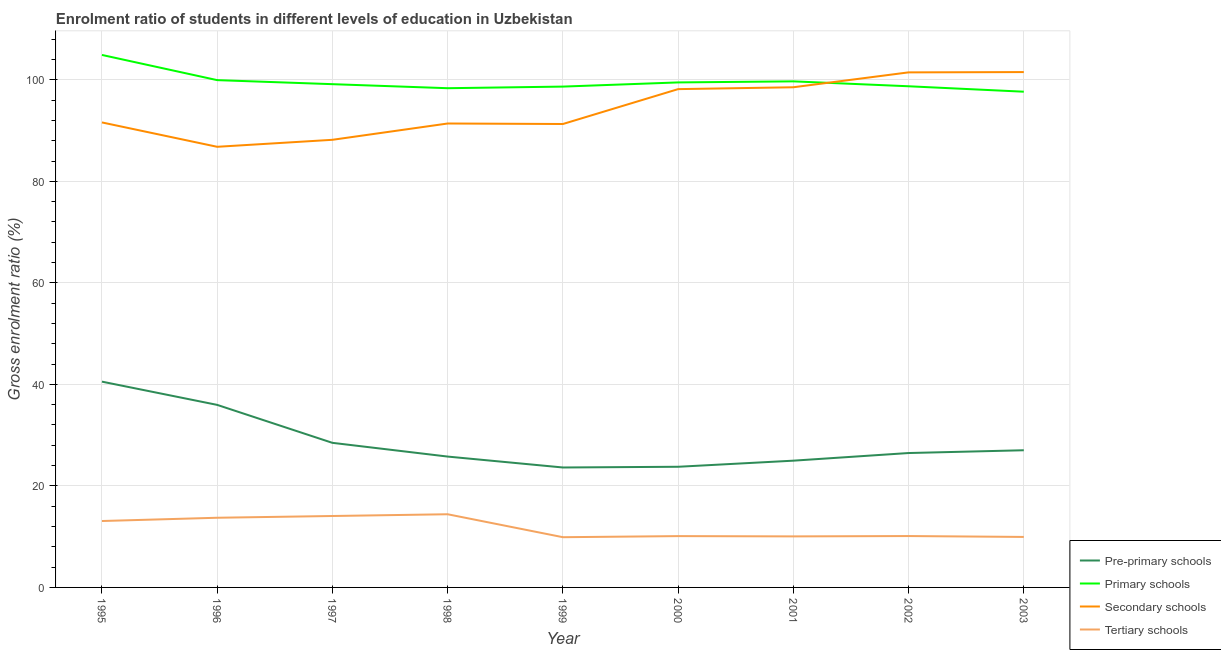How many different coloured lines are there?
Keep it short and to the point. 4. Does the line corresponding to gross enrolment ratio in pre-primary schools intersect with the line corresponding to gross enrolment ratio in secondary schools?
Offer a terse response. No. Is the number of lines equal to the number of legend labels?
Keep it short and to the point. Yes. What is the gross enrolment ratio in tertiary schools in 2003?
Your answer should be very brief. 9.95. Across all years, what is the maximum gross enrolment ratio in secondary schools?
Your answer should be compact. 101.52. Across all years, what is the minimum gross enrolment ratio in tertiary schools?
Your answer should be very brief. 9.9. In which year was the gross enrolment ratio in primary schools maximum?
Provide a succinct answer. 1995. In which year was the gross enrolment ratio in tertiary schools minimum?
Your answer should be very brief. 1999. What is the total gross enrolment ratio in secondary schools in the graph?
Ensure brevity in your answer.  848.95. What is the difference between the gross enrolment ratio in pre-primary schools in 2000 and that in 2002?
Your response must be concise. -2.71. What is the difference between the gross enrolment ratio in pre-primary schools in 2002 and the gross enrolment ratio in secondary schools in 1999?
Offer a very short reply. -64.82. What is the average gross enrolment ratio in primary schools per year?
Your answer should be very brief. 99.62. In the year 1998, what is the difference between the gross enrolment ratio in primary schools and gross enrolment ratio in secondary schools?
Give a very brief answer. 6.95. In how many years, is the gross enrolment ratio in primary schools greater than 20 %?
Your answer should be compact. 9. What is the ratio of the gross enrolment ratio in primary schools in 1999 to that in 2002?
Keep it short and to the point. 1. Is the gross enrolment ratio in secondary schools in 1996 less than that in 1999?
Offer a terse response. Yes. What is the difference between the highest and the second highest gross enrolment ratio in primary schools?
Keep it short and to the point. 4.96. What is the difference between the highest and the lowest gross enrolment ratio in primary schools?
Provide a succinct answer. 7.24. Is the sum of the gross enrolment ratio in pre-primary schools in 1995 and 1997 greater than the maximum gross enrolment ratio in tertiary schools across all years?
Offer a terse response. Yes. Is it the case that in every year, the sum of the gross enrolment ratio in secondary schools and gross enrolment ratio in primary schools is greater than the sum of gross enrolment ratio in tertiary schools and gross enrolment ratio in pre-primary schools?
Keep it short and to the point. Yes. How many lines are there?
Your answer should be compact. 4. How many years are there in the graph?
Give a very brief answer. 9. Are the values on the major ticks of Y-axis written in scientific E-notation?
Your response must be concise. No. Does the graph contain grids?
Provide a short and direct response. Yes. Where does the legend appear in the graph?
Ensure brevity in your answer.  Bottom right. What is the title of the graph?
Ensure brevity in your answer.  Enrolment ratio of students in different levels of education in Uzbekistan. Does "Secondary" appear as one of the legend labels in the graph?
Make the answer very short. No. What is the label or title of the X-axis?
Keep it short and to the point. Year. What is the Gross enrolment ratio (%) of Pre-primary schools in 1995?
Give a very brief answer. 40.54. What is the Gross enrolment ratio (%) of Primary schools in 1995?
Offer a terse response. 104.9. What is the Gross enrolment ratio (%) in Secondary schools in 1995?
Make the answer very short. 91.6. What is the Gross enrolment ratio (%) of Tertiary schools in 1995?
Keep it short and to the point. 13.08. What is the Gross enrolment ratio (%) of Pre-primary schools in 1996?
Provide a succinct answer. 35.96. What is the Gross enrolment ratio (%) of Primary schools in 1996?
Offer a terse response. 99.94. What is the Gross enrolment ratio (%) in Secondary schools in 1996?
Keep it short and to the point. 86.8. What is the Gross enrolment ratio (%) of Tertiary schools in 1996?
Your response must be concise. 13.73. What is the Gross enrolment ratio (%) of Pre-primary schools in 1997?
Make the answer very short. 28.48. What is the Gross enrolment ratio (%) of Primary schools in 1997?
Provide a succinct answer. 99.14. What is the Gross enrolment ratio (%) in Secondary schools in 1997?
Provide a short and direct response. 88.18. What is the Gross enrolment ratio (%) in Tertiary schools in 1997?
Your answer should be compact. 14.07. What is the Gross enrolment ratio (%) in Pre-primary schools in 1998?
Offer a very short reply. 25.78. What is the Gross enrolment ratio (%) of Primary schools in 1998?
Offer a terse response. 98.34. What is the Gross enrolment ratio (%) in Secondary schools in 1998?
Offer a very short reply. 91.39. What is the Gross enrolment ratio (%) of Tertiary schools in 1998?
Ensure brevity in your answer.  14.41. What is the Gross enrolment ratio (%) in Pre-primary schools in 1999?
Make the answer very short. 23.63. What is the Gross enrolment ratio (%) of Primary schools in 1999?
Keep it short and to the point. 98.66. What is the Gross enrolment ratio (%) in Secondary schools in 1999?
Provide a succinct answer. 91.29. What is the Gross enrolment ratio (%) of Tertiary schools in 1999?
Give a very brief answer. 9.9. What is the Gross enrolment ratio (%) in Pre-primary schools in 2000?
Offer a terse response. 23.77. What is the Gross enrolment ratio (%) of Primary schools in 2000?
Offer a terse response. 99.48. What is the Gross enrolment ratio (%) in Secondary schools in 2000?
Give a very brief answer. 98.16. What is the Gross enrolment ratio (%) in Tertiary schools in 2000?
Your response must be concise. 10.11. What is the Gross enrolment ratio (%) of Pre-primary schools in 2001?
Offer a very short reply. 24.97. What is the Gross enrolment ratio (%) of Primary schools in 2001?
Your response must be concise. 99.69. What is the Gross enrolment ratio (%) of Secondary schools in 2001?
Offer a terse response. 98.53. What is the Gross enrolment ratio (%) in Tertiary schools in 2001?
Give a very brief answer. 10.06. What is the Gross enrolment ratio (%) of Pre-primary schools in 2002?
Make the answer very short. 26.47. What is the Gross enrolment ratio (%) of Primary schools in 2002?
Keep it short and to the point. 98.73. What is the Gross enrolment ratio (%) of Secondary schools in 2002?
Your response must be concise. 101.46. What is the Gross enrolment ratio (%) in Tertiary schools in 2002?
Provide a short and direct response. 10.12. What is the Gross enrolment ratio (%) in Pre-primary schools in 2003?
Provide a succinct answer. 27.02. What is the Gross enrolment ratio (%) of Primary schools in 2003?
Ensure brevity in your answer.  97.65. What is the Gross enrolment ratio (%) of Secondary schools in 2003?
Offer a very short reply. 101.52. What is the Gross enrolment ratio (%) of Tertiary schools in 2003?
Your answer should be very brief. 9.95. Across all years, what is the maximum Gross enrolment ratio (%) of Pre-primary schools?
Your answer should be very brief. 40.54. Across all years, what is the maximum Gross enrolment ratio (%) of Primary schools?
Offer a terse response. 104.9. Across all years, what is the maximum Gross enrolment ratio (%) of Secondary schools?
Ensure brevity in your answer.  101.52. Across all years, what is the maximum Gross enrolment ratio (%) of Tertiary schools?
Ensure brevity in your answer.  14.41. Across all years, what is the minimum Gross enrolment ratio (%) in Pre-primary schools?
Provide a succinct answer. 23.63. Across all years, what is the minimum Gross enrolment ratio (%) in Primary schools?
Your response must be concise. 97.65. Across all years, what is the minimum Gross enrolment ratio (%) in Secondary schools?
Offer a very short reply. 86.8. Across all years, what is the minimum Gross enrolment ratio (%) in Tertiary schools?
Give a very brief answer. 9.9. What is the total Gross enrolment ratio (%) of Pre-primary schools in the graph?
Your answer should be compact. 256.62. What is the total Gross enrolment ratio (%) of Primary schools in the graph?
Provide a short and direct response. 896.54. What is the total Gross enrolment ratio (%) of Secondary schools in the graph?
Ensure brevity in your answer.  848.95. What is the total Gross enrolment ratio (%) in Tertiary schools in the graph?
Offer a very short reply. 105.42. What is the difference between the Gross enrolment ratio (%) in Pre-primary schools in 1995 and that in 1996?
Offer a terse response. 4.58. What is the difference between the Gross enrolment ratio (%) of Primary schools in 1995 and that in 1996?
Provide a short and direct response. 4.96. What is the difference between the Gross enrolment ratio (%) of Secondary schools in 1995 and that in 1996?
Provide a short and direct response. 4.8. What is the difference between the Gross enrolment ratio (%) in Tertiary schools in 1995 and that in 1996?
Provide a succinct answer. -0.64. What is the difference between the Gross enrolment ratio (%) in Pre-primary schools in 1995 and that in 1997?
Your answer should be very brief. 12.06. What is the difference between the Gross enrolment ratio (%) in Primary schools in 1995 and that in 1997?
Keep it short and to the point. 5.76. What is the difference between the Gross enrolment ratio (%) in Secondary schools in 1995 and that in 1997?
Your answer should be compact. 3.42. What is the difference between the Gross enrolment ratio (%) in Tertiary schools in 1995 and that in 1997?
Provide a succinct answer. -0.99. What is the difference between the Gross enrolment ratio (%) in Pre-primary schools in 1995 and that in 1998?
Make the answer very short. 14.76. What is the difference between the Gross enrolment ratio (%) in Primary schools in 1995 and that in 1998?
Offer a very short reply. 6.55. What is the difference between the Gross enrolment ratio (%) of Secondary schools in 1995 and that in 1998?
Provide a succinct answer. 0.21. What is the difference between the Gross enrolment ratio (%) of Tertiary schools in 1995 and that in 1998?
Your answer should be compact. -1.33. What is the difference between the Gross enrolment ratio (%) in Pre-primary schools in 1995 and that in 1999?
Ensure brevity in your answer.  16.91. What is the difference between the Gross enrolment ratio (%) in Primary schools in 1995 and that in 1999?
Give a very brief answer. 6.24. What is the difference between the Gross enrolment ratio (%) in Secondary schools in 1995 and that in 1999?
Your answer should be very brief. 0.31. What is the difference between the Gross enrolment ratio (%) of Tertiary schools in 1995 and that in 1999?
Ensure brevity in your answer.  3.19. What is the difference between the Gross enrolment ratio (%) of Pre-primary schools in 1995 and that in 2000?
Offer a very short reply. 16.77. What is the difference between the Gross enrolment ratio (%) in Primary schools in 1995 and that in 2000?
Offer a terse response. 5.41. What is the difference between the Gross enrolment ratio (%) in Secondary schools in 1995 and that in 2000?
Your response must be concise. -6.56. What is the difference between the Gross enrolment ratio (%) in Tertiary schools in 1995 and that in 2000?
Make the answer very short. 2.97. What is the difference between the Gross enrolment ratio (%) of Pre-primary schools in 1995 and that in 2001?
Make the answer very short. 15.57. What is the difference between the Gross enrolment ratio (%) of Primary schools in 1995 and that in 2001?
Ensure brevity in your answer.  5.2. What is the difference between the Gross enrolment ratio (%) in Secondary schools in 1995 and that in 2001?
Your answer should be compact. -6.93. What is the difference between the Gross enrolment ratio (%) in Tertiary schools in 1995 and that in 2001?
Offer a terse response. 3.03. What is the difference between the Gross enrolment ratio (%) in Pre-primary schools in 1995 and that in 2002?
Offer a very short reply. 14.06. What is the difference between the Gross enrolment ratio (%) of Primary schools in 1995 and that in 2002?
Your answer should be very brief. 6.17. What is the difference between the Gross enrolment ratio (%) in Secondary schools in 1995 and that in 2002?
Provide a short and direct response. -9.86. What is the difference between the Gross enrolment ratio (%) in Tertiary schools in 1995 and that in 2002?
Provide a succinct answer. 2.96. What is the difference between the Gross enrolment ratio (%) in Pre-primary schools in 1995 and that in 2003?
Keep it short and to the point. 13.52. What is the difference between the Gross enrolment ratio (%) in Primary schools in 1995 and that in 2003?
Offer a terse response. 7.24. What is the difference between the Gross enrolment ratio (%) in Secondary schools in 1995 and that in 2003?
Offer a terse response. -9.92. What is the difference between the Gross enrolment ratio (%) of Tertiary schools in 1995 and that in 2003?
Keep it short and to the point. 3.14. What is the difference between the Gross enrolment ratio (%) of Pre-primary schools in 1996 and that in 1997?
Keep it short and to the point. 7.48. What is the difference between the Gross enrolment ratio (%) of Primary schools in 1996 and that in 1997?
Keep it short and to the point. 0.8. What is the difference between the Gross enrolment ratio (%) in Secondary schools in 1996 and that in 1997?
Give a very brief answer. -1.38. What is the difference between the Gross enrolment ratio (%) of Tertiary schools in 1996 and that in 1997?
Your answer should be very brief. -0.34. What is the difference between the Gross enrolment ratio (%) of Pre-primary schools in 1996 and that in 1998?
Provide a short and direct response. 10.18. What is the difference between the Gross enrolment ratio (%) of Primary schools in 1996 and that in 1998?
Offer a terse response. 1.59. What is the difference between the Gross enrolment ratio (%) in Secondary schools in 1996 and that in 1998?
Make the answer very short. -4.59. What is the difference between the Gross enrolment ratio (%) in Tertiary schools in 1996 and that in 1998?
Keep it short and to the point. -0.69. What is the difference between the Gross enrolment ratio (%) of Pre-primary schools in 1996 and that in 1999?
Your answer should be compact. 12.33. What is the difference between the Gross enrolment ratio (%) of Primary schools in 1996 and that in 1999?
Give a very brief answer. 1.27. What is the difference between the Gross enrolment ratio (%) of Secondary schools in 1996 and that in 1999?
Your answer should be very brief. -4.49. What is the difference between the Gross enrolment ratio (%) of Tertiary schools in 1996 and that in 1999?
Offer a terse response. 3.83. What is the difference between the Gross enrolment ratio (%) of Pre-primary schools in 1996 and that in 2000?
Make the answer very short. 12.19. What is the difference between the Gross enrolment ratio (%) in Primary schools in 1996 and that in 2000?
Your answer should be very brief. 0.45. What is the difference between the Gross enrolment ratio (%) in Secondary schools in 1996 and that in 2000?
Offer a very short reply. -11.36. What is the difference between the Gross enrolment ratio (%) in Tertiary schools in 1996 and that in 2000?
Your response must be concise. 3.62. What is the difference between the Gross enrolment ratio (%) in Pre-primary schools in 1996 and that in 2001?
Ensure brevity in your answer.  10.99. What is the difference between the Gross enrolment ratio (%) in Primary schools in 1996 and that in 2001?
Give a very brief answer. 0.24. What is the difference between the Gross enrolment ratio (%) in Secondary schools in 1996 and that in 2001?
Ensure brevity in your answer.  -11.73. What is the difference between the Gross enrolment ratio (%) of Tertiary schools in 1996 and that in 2001?
Offer a very short reply. 3.67. What is the difference between the Gross enrolment ratio (%) of Pre-primary schools in 1996 and that in 2002?
Your answer should be very brief. 9.49. What is the difference between the Gross enrolment ratio (%) in Primary schools in 1996 and that in 2002?
Provide a succinct answer. 1.21. What is the difference between the Gross enrolment ratio (%) of Secondary schools in 1996 and that in 2002?
Make the answer very short. -14.66. What is the difference between the Gross enrolment ratio (%) in Tertiary schools in 1996 and that in 2002?
Your answer should be compact. 3.6. What is the difference between the Gross enrolment ratio (%) of Pre-primary schools in 1996 and that in 2003?
Your response must be concise. 8.94. What is the difference between the Gross enrolment ratio (%) in Primary schools in 1996 and that in 2003?
Offer a very short reply. 2.28. What is the difference between the Gross enrolment ratio (%) in Secondary schools in 1996 and that in 2003?
Provide a short and direct response. -14.72. What is the difference between the Gross enrolment ratio (%) in Tertiary schools in 1996 and that in 2003?
Keep it short and to the point. 3.78. What is the difference between the Gross enrolment ratio (%) in Pre-primary schools in 1997 and that in 1998?
Offer a terse response. 2.7. What is the difference between the Gross enrolment ratio (%) of Primary schools in 1997 and that in 1998?
Keep it short and to the point. 0.8. What is the difference between the Gross enrolment ratio (%) in Secondary schools in 1997 and that in 1998?
Ensure brevity in your answer.  -3.21. What is the difference between the Gross enrolment ratio (%) in Tertiary schools in 1997 and that in 1998?
Make the answer very short. -0.34. What is the difference between the Gross enrolment ratio (%) in Pre-primary schools in 1997 and that in 1999?
Your answer should be compact. 4.85. What is the difference between the Gross enrolment ratio (%) in Primary schools in 1997 and that in 1999?
Ensure brevity in your answer.  0.48. What is the difference between the Gross enrolment ratio (%) of Secondary schools in 1997 and that in 1999?
Provide a short and direct response. -3.11. What is the difference between the Gross enrolment ratio (%) of Tertiary schools in 1997 and that in 1999?
Ensure brevity in your answer.  4.18. What is the difference between the Gross enrolment ratio (%) of Pre-primary schools in 1997 and that in 2000?
Your response must be concise. 4.71. What is the difference between the Gross enrolment ratio (%) in Primary schools in 1997 and that in 2000?
Ensure brevity in your answer.  -0.34. What is the difference between the Gross enrolment ratio (%) of Secondary schools in 1997 and that in 2000?
Give a very brief answer. -9.98. What is the difference between the Gross enrolment ratio (%) of Tertiary schools in 1997 and that in 2000?
Keep it short and to the point. 3.96. What is the difference between the Gross enrolment ratio (%) in Pre-primary schools in 1997 and that in 2001?
Provide a succinct answer. 3.51. What is the difference between the Gross enrolment ratio (%) of Primary schools in 1997 and that in 2001?
Your response must be concise. -0.55. What is the difference between the Gross enrolment ratio (%) of Secondary schools in 1997 and that in 2001?
Your answer should be compact. -10.35. What is the difference between the Gross enrolment ratio (%) of Tertiary schools in 1997 and that in 2001?
Your response must be concise. 4.02. What is the difference between the Gross enrolment ratio (%) in Pre-primary schools in 1997 and that in 2002?
Provide a succinct answer. 2.01. What is the difference between the Gross enrolment ratio (%) in Primary schools in 1997 and that in 2002?
Offer a very short reply. 0.41. What is the difference between the Gross enrolment ratio (%) in Secondary schools in 1997 and that in 2002?
Make the answer very short. -13.28. What is the difference between the Gross enrolment ratio (%) of Tertiary schools in 1997 and that in 2002?
Provide a succinct answer. 3.95. What is the difference between the Gross enrolment ratio (%) in Pre-primary schools in 1997 and that in 2003?
Your answer should be compact. 1.46. What is the difference between the Gross enrolment ratio (%) in Primary schools in 1997 and that in 2003?
Make the answer very short. 1.49. What is the difference between the Gross enrolment ratio (%) of Secondary schools in 1997 and that in 2003?
Offer a terse response. -13.34. What is the difference between the Gross enrolment ratio (%) in Tertiary schools in 1997 and that in 2003?
Provide a succinct answer. 4.12. What is the difference between the Gross enrolment ratio (%) in Pre-primary schools in 1998 and that in 1999?
Your answer should be compact. 2.15. What is the difference between the Gross enrolment ratio (%) of Primary schools in 1998 and that in 1999?
Give a very brief answer. -0.32. What is the difference between the Gross enrolment ratio (%) of Secondary schools in 1998 and that in 1999?
Offer a very short reply. 0.1. What is the difference between the Gross enrolment ratio (%) in Tertiary schools in 1998 and that in 1999?
Your answer should be compact. 4.52. What is the difference between the Gross enrolment ratio (%) of Pre-primary schools in 1998 and that in 2000?
Your response must be concise. 2.01. What is the difference between the Gross enrolment ratio (%) in Primary schools in 1998 and that in 2000?
Your answer should be very brief. -1.14. What is the difference between the Gross enrolment ratio (%) in Secondary schools in 1998 and that in 2000?
Your response must be concise. -6.77. What is the difference between the Gross enrolment ratio (%) in Tertiary schools in 1998 and that in 2000?
Give a very brief answer. 4.3. What is the difference between the Gross enrolment ratio (%) of Pre-primary schools in 1998 and that in 2001?
Your answer should be very brief. 0.81. What is the difference between the Gross enrolment ratio (%) of Primary schools in 1998 and that in 2001?
Offer a terse response. -1.35. What is the difference between the Gross enrolment ratio (%) in Secondary schools in 1998 and that in 2001?
Keep it short and to the point. -7.14. What is the difference between the Gross enrolment ratio (%) in Tertiary schools in 1998 and that in 2001?
Provide a short and direct response. 4.36. What is the difference between the Gross enrolment ratio (%) of Pre-primary schools in 1998 and that in 2002?
Make the answer very short. -0.7. What is the difference between the Gross enrolment ratio (%) of Primary schools in 1998 and that in 2002?
Provide a short and direct response. -0.38. What is the difference between the Gross enrolment ratio (%) in Secondary schools in 1998 and that in 2002?
Provide a succinct answer. -10.07. What is the difference between the Gross enrolment ratio (%) in Tertiary schools in 1998 and that in 2002?
Offer a terse response. 4.29. What is the difference between the Gross enrolment ratio (%) of Pre-primary schools in 1998 and that in 2003?
Make the answer very short. -1.24. What is the difference between the Gross enrolment ratio (%) of Primary schools in 1998 and that in 2003?
Provide a succinct answer. 0.69. What is the difference between the Gross enrolment ratio (%) in Secondary schools in 1998 and that in 2003?
Give a very brief answer. -10.13. What is the difference between the Gross enrolment ratio (%) in Tertiary schools in 1998 and that in 2003?
Provide a short and direct response. 4.47. What is the difference between the Gross enrolment ratio (%) of Pre-primary schools in 1999 and that in 2000?
Make the answer very short. -0.14. What is the difference between the Gross enrolment ratio (%) in Primary schools in 1999 and that in 2000?
Give a very brief answer. -0.82. What is the difference between the Gross enrolment ratio (%) in Secondary schools in 1999 and that in 2000?
Give a very brief answer. -6.87. What is the difference between the Gross enrolment ratio (%) in Tertiary schools in 1999 and that in 2000?
Provide a succinct answer. -0.21. What is the difference between the Gross enrolment ratio (%) of Pre-primary schools in 1999 and that in 2001?
Offer a very short reply. -1.34. What is the difference between the Gross enrolment ratio (%) in Primary schools in 1999 and that in 2001?
Your answer should be very brief. -1.03. What is the difference between the Gross enrolment ratio (%) in Secondary schools in 1999 and that in 2001?
Keep it short and to the point. -7.24. What is the difference between the Gross enrolment ratio (%) of Tertiary schools in 1999 and that in 2001?
Give a very brief answer. -0.16. What is the difference between the Gross enrolment ratio (%) of Pre-primary schools in 1999 and that in 2002?
Make the answer very short. -2.85. What is the difference between the Gross enrolment ratio (%) of Primary schools in 1999 and that in 2002?
Offer a very short reply. -0.06. What is the difference between the Gross enrolment ratio (%) of Secondary schools in 1999 and that in 2002?
Your answer should be compact. -10.17. What is the difference between the Gross enrolment ratio (%) in Tertiary schools in 1999 and that in 2002?
Your answer should be very brief. -0.23. What is the difference between the Gross enrolment ratio (%) of Pre-primary schools in 1999 and that in 2003?
Give a very brief answer. -3.39. What is the difference between the Gross enrolment ratio (%) in Secondary schools in 1999 and that in 2003?
Your answer should be very brief. -10.23. What is the difference between the Gross enrolment ratio (%) of Tertiary schools in 1999 and that in 2003?
Provide a succinct answer. -0.05. What is the difference between the Gross enrolment ratio (%) in Pre-primary schools in 2000 and that in 2001?
Provide a succinct answer. -1.2. What is the difference between the Gross enrolment ratio (%) of Primary schools in 2000 and that in 2001?
Offer a terse response. -0.21. What is the difference between the Gross enrolment ratio (%) in Secondary schools in 2000 and that in 2001?
Make the answer very short. -0.37. What is the difference between the Gross enrolment ratio (%) in Tertiary schools in 2000 and that in 2001?
Keep it short and to the point. 0.05. What is the difference between the Gross enrolment ratio (%) of Pre-primary schools in 2000 and that in 2002?
Your response must be concise. -2.71. What is the difference between the Gross enrolment ratio (%) in Primary schools in 2000 and that in 2002?
Give a very brief answer. 0.76. What is the difference between the Gross enrolment ratio (%) of Secondary schools in 2000 and that in 2002?
Ensure brevity in your answer.  -3.3. What is the difference between the Gross enrolment ratio (%) of Tertiary schools in 2000 and that in 2002?
Provide a short and direct response. -0.01. What is the difference between the Gross enrolment ratio (%) of Pre-primary schools in 2000 and that in 2003?
Keep it short and to the point. -3.25. What is the difference between the Gross enrolment ratio (%) in Primary schools in 2000 and that in 2003?
Ensure brevity in your answer.  1.83. What is the difference between the Gross enrolment ratio (%) of Secondary schools in 2000 and that in 2003?
Your answer should be compact. -3.36. What is the difference between the Gross enrolment ratio (%) of Tertiary schools in 2000 and that in 2003?
Provide a succinct answer. 0.16. What is the difference between the Gross enrolment ratio (%) in Pre-primary schools in 2001 and that in 2002?
Offer a terse response. -1.5. What is the difference between the Gross enrolment ratio (%) in Primary schools in 2001 and that in 2002?
Give a very brief answer. 0.97. What is the difference between the Gross enrolment ratio (%) in Secondary schools in 2001 and that in 2002?
Offer a terse response. -2.93. What is the difference between the Gross enrolment ratio (%) in Tertiary schools in 2001 and that in 2002?
Offer a very short reply. -0.07. What is the difference between the Gross enrolment ratio (%) in Pre-primary schools in 2001 and that in 2003?
Give a very brief answer. -2.05. What is the difference between the Gross enrolment ratio (%) in Primary schools in 2001 and that in 2003?
Provide a succinct answer. 2.04. What is the difference between the Gross enrolment ratio (%) of Secondary schools in 2001 and that in 2003?
Give a very brief answer. -2.99. What is the difference between the Gross enrolment ratio (%) in Tertiary schools in 2001 and that in 2003?
Make the answer very short. 0.11. What is the difference between the Gross enrolment ratio (%) in Pre-primary schools in 2002 and that in 2003?
Your response must be concise. -0.55. What is the difference between the Gross enrolment ratio (%) in Primary schools in 2002 and that in 2003?
Your response must be concise. 1.07. What is the difference between the Gross enrolment ratio (%) of Secondary schools in 2002 and that in 2003?
Your response must be concise. -0.06. What is the difference between the Gross enrolment ratio (%) of Tertiary schools in 2002 and that in 2003?
Provide a succinct answer. 0.17. What is the difference between the Gross enrolment ratio (%) in Pre-primary schools in 1995 and the Gross enrolment ratio (%) in Primary schools in 1996?
Offer a terse response. -59.4. What is the difference between the Gross enrolment ratio (%) of Pre-primary schools in 1995 and the Gross enrolment ratio (%) of Secondary schools in 1996?
Make the answer very short. -46.26. What is the difference between the Gross enrolment ratio (%) in Pre-primary schools in 1995 and the Gross enrolment ratio (%) in Tertiary schools in 1996?
Offer a very short reply. 26.81. What is the difference between the Gross enrolment ratio (%) in Primary schools in 1995 and the Gross enrolment ratio (%) in Secondary schools in 1996?
Ensure brevity in your answer.  18.1. What is the difference between the Gross enrolment ratio (%) of Primary schools in 1995 and the Gross enrolment ratio (%) of Tertiary schools in 1996?
Provide a succinct answer. 91.17. What is the difference between the Gross enrolment ratio (%) in Secondary schools in 1995 and the Gross enrolment ratio (%) in Tertiary schools in 1996?
Ensure brevity in your answer.  77.88. What is the difference between the Gross enrolment ratio (%) of Pre-primary schools in 1995 and the Gross enrolment ratio (%) of Primary schools in 1997?
Make the answer very short. -58.6. What is the difference between the Gross enrolment ratio (%) in Pre-primary schools in 1995 and the Gross enrolment ratio (%) in Secondary schools in 1997?
Ensure brevity in your answer.  -47.64. What is the difference between the Gross enrolment ratio (%) of Pre-primary schools in 1995 and the Gross enrolment ratio (%) of Tertiary schools in 1997?
Make the answer very short. 26.47. What is the difference between the Gross enrolment ratio (%) in Primary schools in 1995 and the Gross enrolment ratio (%) in Secondary schools in 1997?
Give a very brief answer. 16.72. What is the difference between the Gross enrolment ratio (%) in Primary schools in 1995 and the Gross enrolment ratio (%) in Tertiary schools in 1997?
Ensure brevity in your answer.  90.83. What is the difference between the Gross enrolment ratio (%) of Secondary schools in 1995 and the Gross enrolment ratio (%) of Tertiary schools in 1997?
Keep it short and to the point. 77.53. What is the difference between the Gross enrolment ratio (%) of Pre-primary schools in 1995 and the Gross enrolment ratio (%) of Primary schools in 1998?
Your response must be concise. -57.8. What is the difference between the Gross enrolment ratio (%) in Pre-primary schools in 1995 and the Gross enrolment ratio (%) in Secondary schools in 1998?
Provide a succinct answer. -50.85. What is the difference between the Gross enrolment ratio (%) of Pre-primary schools in 1995 and the Gross enrolment ratio (%) of Tertiary schools in 1998?
Your answer should be compact. 26.12. What is the difference between the Gross enrolment ratio (%) in Primary schools in 1995 and the Gross enrolment ratio (%) in Secondary schools in 1998?
Make the answer very short. 13.51. What is the difference between the Gross enrolment ratio (%) in Primary schools in 1995 and the Gross enrolment ratio (%) in Tertiary schools in 1998?
Offer a very short reply. 90.48. What is the difference between the Gross enrolment ratio (%) in Secondary schools in 1995 and the Gross enrolment ratio (%) in Tertiary schools in 1998?
Give a very brief answer. 77.19. What is the difference between the Gross enrolment ratio (%) of Pre-primary schools in 1995 and the Gross enrolment ratio (%) of Primary schools in 1999?
Provide a short and direct response. -58.12. What is the difference between the Gross enrolment ratio (%) in Pre-primary schools in 1995 and the Gross enrolment ratio (%) in Secondary schools in 1999?
Keep it short and to the point. -50.75. What is the difference between the Gross enrolment ratio (%) in Pre-primary schools in 1995 and the Gross enrolment ratio (%) in Tertiary schools in 1999?
Provide a short and direct response. 30.64. What is the difference between the Gross enrolment ratio (%) of Primary schools in 1995 and the Gross enrolment ratio (%) of Secondary schools in 1999?
Make the answer very short. 13.61. What is the difference between the Gross enrolment ratio (%) in Primary schools in 1995 and the Gross enrolment ratio (%) in Tertiary schools in 1999?
Give a very brief answer. 95. What is the difference between the Gross enrolment ratio (%) in Secondary schools in 1995 and the Gross enrolment ratio (%) in Tertiary schools in 1999?
Your answer should be compact. 81.71. What is the difference between the Gross enrolment ratio (%) of Pre-primary schools in 1995 and the Gross enrolment ratio (%) of Primary schools in 2000?
Offer a terse response. -58.94. What is the difference between the Gross enrolment ratio (%) in Pre-primary schools in 1995 and the Gross enrolment ratio (%) in Secondary schools in 2000?
Offer a terse response. -57.62. What is the difference between the Gross enrolment ratio (%) in Pre-primary schools in 1995 and the Gross enrolment ratio (%) in Tertiary schools in 2000?
Keep it short and to the point. 30.43. What is the difference between the Gross enrolment ratio (%) in Primary schools in 1995 and the Gross enrolment ratio (%) in Secondary schools in 2000?
Make the answer very short. 6.73. What is the difference between the Gross enrolment ratio (%) in Primary schools in 1995 and the Gross enrolment ratio (%) in Tertiary schools in 2000?
Keep it short and to the point. 94.79. What is the difference between the Gross enrolment ratio (%) in Secondary schools in 1995 and the Gross enrolment ratio (%) in Tertiary schools in 2000?
Make the answer very short. 81.49. What is the difference between the Gross enrolment ratio (%) of Pre-primary schools in 1995 and the Gross enrolment ratio (%) of Primary schools in 2001?
Provide a succinct answer. -59.15. What is the difference between the Gross enrolment ratio (%) in Pre-primary schools in 1995 and the Gross enrolment ratio (%) in Secondary schools in 2001?
Offer a very short reply. -57.99. What is the difference between the Gross enrolment ratio (%) of Pre-primary schools in 1995 and the Gross enrolment ratio (%) of Tertiary schools in 2001?
Provide a succinct answer. 30.48. What is the difference between the Gross enrolment ratio (%) in Primary schools in 1995 and the Gross enrolment ratio (%) in Secondary schools in 2001?
Your answer should be compact. 6.37. What is the difference between the Gross enrolment ratio (%) in Primary schools in 1995 and the Gross enrolment ratio (%) in Tertiary schools in 2001?
Your answer should be compact. 94.84. What is the difference between the Gross enrolment ratio (%) in Secondary schools in 1995 and the Gross enrolment ratio (%) in Tertiary schools in 2001?
Provide a short and direct response. 81.55. What is the difference between the Gross enrolment ratio (%) of Pre-primary schools in 1995 and the Gross enrolment ratio (%) of Primary schools in 2002?
Make the answer very short. -58.19. What is the difference between the Gross enrolment ratio (%) of Pre-primary schools in 1995 and the Gross enrolment ratio (%) of Secondary schools in 2002?
Make the answer very short. -60.92. What is the difference between the Gross enrolment ratio (%) in Pre-primary schools in 1995 and the Gross enrolment ratio (%) in Tertiary schools in 2002?
Your answer should be compact. 30.42. What is the difference between the Gross enrolment ratio (%) of Primary schools in 1995 and the Gross enrolment ratio (%) of Secondary schools in 2002?
Ensure brevity in your answer.  3.43. What is the difference between the Gross enrolment ratio (%) in Primary schools in 1995 and the Gross enrolment ratio (%) in Tertiary schools in 2002?
Offer a very short reply. 94.78. What is the difference between the Gross enrolment ratio (%) of Secondary schools in 1995 and the Gross enrolment ratio (%) of Tertiary schools in 2002?
Your answer should be compact. 81.48. What is the difference between the Gross enrolment ratio (%) of Pre-primary schools in 1995 and the Gross enrolment ratio (%) of Primary schools in 2003?
Keep it short and to the point. -57.12. What is the difference between the Gross enrolment ratio (%) of Pre-primary schools in 1995 and the Gross enrolment ratio (%) of Secondary schools in 2003?
Keep it short and to the point. -60.98. What is the difference between the Gross enrolment ratio (%) in Pre-primary schools in 1995 and the Gross enrolment ratio (%) in Tertiary schools in 2003?
Your response must be concise. 30.59. What is the difference between the Gross enrolment ratio (%) in Primary schools in 1995 and the Gross enrolment ratio (%) in Secondary schools in 2003?
Offer a very short reply. 3.38. What is the difference between the Gross enrolment ratio (%) in Primary schools in 1995 and the Gross enrolment ratio (%) in Tertiary schools in 2003?
Your answer should be compact. 94.95. What is the difference between the Gross enrolment ratio (%) of Secondary schools in 1995 and the Gross enrolment ratio (%) of Tertiary schools in 2003?
Your response must be concise. 81.66. What is the difference between the Gross enrolment ratio (%) of Pre-primary schools in 1996 and the Gross enrolment ratio (%) of Primary schools in 1997?
Provide a short and direct response. -63.18. What is the difference between the Gross enrolment ratio (%) of Pre-primary schools in 1996 and the Gross enrolment ratio (%) of Secondary schools in 1997?
Provide a succinct answer. -52.22. What is the difference between the Gross enrolment ratio (%) of Pre-primary schools in 1996 and the Gross enrolment ratio (%) of Tertiary schools in 1997?
Provide a succinct answer. 21.89. What is the difference between the Gross enrolment ratio (%) of Primary schools in 1996 and the Gross enrolment ratio (%) of Secondary schools in 1997?
Make the answer very short. 11.76. What is the difference between the Gross enrolment ratio (%) of Primary schools in 1996 and the Gross enrolment ratio (%) of Tertiary schools in 1997?
Provide a succinct answer. 85.87. What is the difference between the Gross enrolment ratio (%) of Secondary schools in 1996 and the Gross enrolment ratio (%) of Tertiary schools in 1997?
Your response must be concise. 72.73. What is the difference between the Gross enrolment ratio (%) of Pre-primary schools in 1996 and the Gross enrolment ratio (%) of Primary schools in 1998?
Keep it short and to the point. -62.38. What is the difference between the Gross enrolment ratio (%) in Pre-primary schools in 1996 and the Gross enrolment ratio (%) in Secondary schools in 1998?
Your answer should be very brief. -55.43. What is the difference between the Gross enrolment ratio (%) of Pre-primary schools in 1996 and the Gross enrolment ratio (%) of Tertiary schools in 1998?
Provide a short and direct response. 21.55. What is the difference between the Gross enrolment ratio (%) in Primary schools in 1996 and the Gross enrolment ratio (%) in Secondary schools in 1998?
Make the answer very short. 8.55. What is the difference between the Gross enrolment ratio (%) in Primary schools in 1996 and the Gross enrolment ratio (%) in Tertiary schools in 1998?
Make the answer very short. 85.52. What is the difference between the Gross enrolment ratio (%) in Secondary schools in 1996 and the Gross enrolment ratio (%) in Tertiary schools in 1998?
Offer a very short reply. 72.39. What is the difference between the Gross enrolment ratio (%) in Pre-primary schools in 1996 and the Gross enrolment ratio (%) in Primary schools in 1999?
Ensure brevity in your answer.  -62.7. What is the difference between the Gross enrolment ratio (%) of Pre-primary schools in 1996 and the Gross enrolment ratio (%) of Secondary schools in 1999?
Provide a succinct answer. -55.33. What is the difference between the Gross enrolment ratio (%) of Pre-primary schools in 1996 and the Gross enrolment ratio (%) of Tertiary schools in 1999?
Your response must be concise. 26.07. What is the difference between the Gross enrolment ratio (%) of Primary schools in 1996 and the Gross enrolment ratio (%) of Secondary schools in 1999?
Make the answer very short. 8.64. What is the difference between the Gross enrolment ratio (%) in Primary schools in 1996 and the Gross enrolment ratio (%) in Tertiary schools in 1999?
Provide a short and direct response. 90.04. What is the difference between the Gross enrolment ratio (%) of Secondary schools in 1996 and the Gross enrolment ratio (%) of Tertiary schools in 1999?
Offer a terse response. 76.91. What is the difference between the Gross enrolment ratio (%) of Pre-primary schools in 1996 and the Gross enrolment ratio (%) of Primary schools in 2000?
Your response must be concise. -63.52. What is the difference between the Gross enrolment ratio (%) of Pre-primary schools in 1996 and the Gross enrolment ratio (%) of Secondary schools in 2000?
Ensure brevity in your answer.  -62.2. What is the difference between the Gross enrolment ratio (%) of Pre-primary schools in 1996 and the Gross enrolment ratio (%) of Tertiary schools in 2000?
Offer a terse response. 25.85. What is the difference between the Gross enrolment ratio (%) of Primary schools in 1996 and the Gross enrolment ratio (%) of Secondary schools in 2000?
Your answer should be compact. 1.77. What is the difference between the Gross enrolment ratio (%) in Primary schools in 1996 and the Gross enrolment ratio (%) in Tertiary schools in 2000?
Ensure brevity in your answer.  89.83. What is the difference between the Gross enrolment ratio (%) in Secondary schools in 1996 and the Gross enrolment ratio (%) in Tertiary schools in 2000?
Ensure brevity in your answer.  76.69. What is the difference between the Gross enrolment ratio (%) in Pre-primary schools in 1996 and the Gross enrolment ratio (%) in Primary schools in 2001?
Offer a terse response. -63.73. What is the difference between the Gross enrolment ratio (%) in Pre-primary schools in 1996 and the Gross enrolment ratio (%) in Secondary schools in 2001?
Ensure brevity in your answer.  -62.57. What is the difference between the Gross enrolment ratio (%) in Pre-primary schools in 1996 and the Gross enrolment ratio (%) in Tertiary schools in 2001?
Offer a very short reply. 25.91. What is the difference between the Gross enrolment ratio (%) in Primary schools in 1996 and the Gross enrolment ratio (%) in Secondary schools in 2001?
Your response must be concise. 1.41. What is the difference between the Gross enrolment ratio (%) in Primary schools in 1996 and the Gross enrolment ratio (%) in Tertiary schools in 2001?
Your response must be concise. 89.88. What is the difference between the Gross enrolment ratio (%) of Secondary schools in 1996 and the Gross enrolment ratio (%) of Tertiary schools in 2001?
Offer a very short reply. 76.75. What is the difference between the Gross enrolment ratio (%) in Pre-primary schools in 1996 and the Gross enrolment ratio (%) in Primary schools in 2002?
Give a very brief answer. -62.77. What is the difference between the Gross enrolment ratio (%) of Pre-primary schools in 1996 and the Gross enrolment ratio (%) of Secondary schools in 2002?
Your answer should be compact. -65.5. What is the difference between the Gross enrolment ratio (%) in Pre-primary schools in 1996 and the Gross enrolment ratio (%) in Tertiary schools in 2002?
Keep it short and to the point. 25.84. What is the difference between the Gross enrolment ratio (%) in Primary schools in 1996 and the Gross enrolment ratio (%) in Secondary schools in 2002?
Ensure brevity in your answer.  -1.53. What is the difference between the Gross enrolment ratio (%) of Primary schools in 1996 and the Gross enrolment ratio (%) of Tertiary schools in 2002?
Keep it short and to the point. 89.81. What is the difference between the Gross enrolment ratio (%) in Secondary schools in 1996 and the Gross enrolment ratio (%) in Tertiary schools in 2002?
Your answer should be very brief. 76.68. What is the difference between the Gross enrolment ratio (%) in Pre-primary schools in 1996 and the Gross enrolment ratio (%) in Primary schools in 2003?
Ensure brevity in your answer.  -61.69. What is the difference between the Gross enrolment ratio (%) in Pre-primary schools in 1996 and the Gross enrolment ratio (%) in Secondary schools in 2003?
Your response must be concise. -65.56. What is the difference between the Gross enrolment ratio (%) in Pre-primary schools in 1996 and the Gross enrolment ratio (%) in Tertiary schools in 2003?
Make the answer very short. 26.01. What is the difference between the Gross enrolment ratio (%) of Primary schools in 1996 and the Gross enrolment ratio (%) of Secondary schools in 2003?
Keep it short and to the point. -1.59. What is the difference between the Gross enrolment ratio (%) of Primary schools in 1996 and the Gross enrolment ratio (%) of Tertiary schools in 2003?
Offer a very short reply. 89.99. What is the difference between the Gross enrolment ratio (%) in Secondary schools in 1996 and the Gross enrolment ratio (%) in Tertiary schools in 2003?
Provide a succinct answer. 76.86. What is the difference between the Gross enrolment ratio (%) of Pre-primary schools in 1997 and the Gross enrolment ratio (%) of Primary schools in 1998?
Offer a terse response. -69.86. What is the difference between the Gross enrolment ratio (%) of Pre-primary schools in 1997 and the Gross enrolment ratio (%) of Secondary schools in 1998?
Ensure brevity in your answer.  -62.91. What is the difference between the Gross enrolment ratio (%) in Pre-primary schools in 1997 and the Gross enrolment ratio (%) in Tertiary schools in 1998?
Offer a terse response. 14.07. What is the difference between the Gross enrolment ratio (%) of Primary schools in 1997 and the Gross enrolment ratio (%) of Secondary schools in 1998?
Your answer should be compact. 7.75. What is the difference between the Gross enrolment ratio (%) of Primary schools in 1997 and the Gross enrolment ratio (%) of Tertiary schools in 1998?
Provide a short and direct response. 84.73. What is the difference between the Gross enrolment ratio (%) of Secondary schools in 1997 and the Gross enrolment ratio (%) of Tertiary schools in 1998?
Your answer should be very brief. 73.77. What is the difference between the Gross enrolment ratio (%) of Pre-primary schools in 1997 and the Gross enrolment ratio (%) of Primary schools in 1999?
Offer a terse response. -70.18. What is the difference between the Gross enrolment ratio (%) in Pre-primary schools in 1997 and the Gross enrolment ratio (%) in Secondary schools in 1999?
Keep it short and to the point. -62.81. What is the difference between the Gross enrolment ratio (%) of Pre-primary schools in 1997 and the Gross enrolment ratio (%) of Tertiary schools in 1999?
Your answer should be very brief. 18.59. What is the difference between the Gross enrolment ratio (%) of Primary schools in 1997 and the Gross enrolment ratio (%) of Secondary schools in 1999?
Provide a succinct answer. 7.85. What is the difference between the Gross enrolment ratio (%) of Primary schools in 1997 and the Gross enrolment ratio (%) of Tertiary schools in 1999?
Give a very brief answer. 89.24. What is the difference between the Gross enrolment ratio (%) of Secondary schools in 1997 and the Gross enrolment ratio (%) of Tertiary schools in 1999?
Provide a succinct answer. 78.28. What is the difference between the Gross enrolment ratio (%) in Pre-primary schools in 1997 and the Gross enrolment ratio (%) in Primary schools in 2000?
Give a very brief answer. -71. What is the difference between the Gross enrolment ratio (%) in Pre-primary schools in 1997 and the Gross enrolment ratio (%) in Secondary schools in 2000?
Offer a very short reply. -69.68. What is the difference between the Gross enrolment ratio (%) in Pre-primary schools in 1997 and the Gross enrolment ratio (%) in Tertiary schools in 2000?
Your answer should be compact. 18.37. What is the difference between the Gross enrolment ratio (%) in Primary schools in 1997 and the Gross enrolment ratio (%) in Secondary schools in 2000?
Offer a very short reply. 0.98. What is the difference between the Gross enrolment ratio (%) of Primary schools in 1997 and the Gross enrolment ratio (%) of Tertiary schools in 2000?
Provide a short and direct response. 89.03. What is the difference between the Gross enrolment ratio (%) in Secondary schools in 1997 and the Gross enrolment ratio (%) in Tertiary schools in 2000?
Give a very brief answer. 78.07. What is the difference between the Gross enrolment ratio (%) of Pre-primary schools in 1997 and the Gross enrolment ratio (%) of Primary schools in 2001?
Offer a very short reply. -71.21. What is the difference between the Gross enrolment ratio (%) of Pre-primary schools in 1997 and the Gross enrolment ratio (%) of Secondary schools in 2001?
Provide a short and direct response. -70.05. What is the difference between the Gross enrolment ratio (%) in Pre-primary schools in 1997 and the Gross enrolment ratio (%) in Tertiary schools in 2001?
Give a very brief answer. 18.43. What is the difference between the Gross enrolment ratio (%) in Primary schools in 1997 and the Gross enrolment ratio (%) in Secondary schools in 2001?
Keep it short and to the point. 0.61. What is the difference between the Gross enrolment ratio (%) of Primary schools in 1997 and the Gross enrolment ratio (%) of Tertiary schools in 2001?
Your answer should be compact. 89.08. What is the difference between the Gross enrolment ratio (%) in Secondary schools in 1997 and the Gross enrolment ratio (%) in Tertiary schools in 2001?
Keep it short and to the point. 78.12. What is the difference between the Gross enrolment ratio (%) of Pre-primary schools in 1997 and the Gross enrolment ratio (%) of Primary schools in 2002?
Your response must be concise. -70.24. What is the difference between the Gross enrolment ratio (%) in Pre-primary schools in 1997 and the Gross enrolment ratio (%) in Secondary schools in 2002?
Offer a very short reply. -72.98. What is the difference between the Gross enrolment ratio (%) of Pre-primary schools in 1997 and the Gross enrolment ratio (%) of Tertiary schools in 2002?
Provide a short and direct response. 18.36. What is the difference between the Gross enrolment ratio (%) in Primary schools in 1997 and the Gross enrolment ratio (%) in Secondary schools in 2002?
Provide a short and direct response. -2.32. What is the difference between the Gross enrolment ratio (%) of Primary schools in 1997 and the Gross enrolment ratio (%) of Tertiary schools in 2002?
Provide a short and direct response. 89.02. What is the difference between the Gross enrolment ratio (%) in Secondary schools in 1997 and the Gross enrolment ratio (%) in Tertiary schools in 2002?
Make the answer very short. 78.06. What is the difference between the Gross enrolment ratio (%) of Pre-primary schools in 1997 and the Gross enrolment ratio (%) of Primary schools in 2003?
Your answer should be compact. -69.17. What is the difference between the Gross enrolment ratio (%) of Pre-primary schools in 1997 and the Gross enrolment ratio (%) of Secondary schools in 2003?
Give a very brief answer. -73.04. What is the difference between the Gross enrolment ratio (%) in Pre-primary schools in 1997 and the Gross enrolment ratio (%) in Tertiary schools in 2003?
Provide a succinct answer. 18.54. What is the difference between the Gross enrolment ratio (%) of Primary schools in 1997 and the Gross enrolment ratio (%) of Secondary schools in 2003?
Provide a short and direct response. -2.38. What is the difference between the Gross enrolment ratio (%) in Primary schools in 1997 and the Gross enrolment ratio (%) in Tertiary schools in 2003?
Your answer should be compact. 89.19. What is the difference between the Gross enrolment ratio (%) of Secondary schools in 1997 and the Gross enrolment ratio (%) of Tertiary schools in 2003?
Make the answer very short. 78.23. What is the difference between the Gross enrolment ratio (%) in Pre-primary schools in 1998 and the Gross enrolment ratio (%) in Primary schools in 1999?
Your response must be concise. -72.88. What is the difference between the Gross enrolment ratio (%) in Pre-primary schools in 1998 and the Gross enrolment ratio (%) in Secondary schools in 1999?
Offer a terse response. -65.51. What is the difference between the Gross enrolment ratio (%) in Pre-primary schools in 1998 and the Gross enrolment ratio (%) in Tertiary schools in 1999?
Offer a terse response. 15.88. What is the difference between the Gross enrolment ratio (%) in Primary schools in 1998 and the Gross enrolment ratio (%) in Secondary schools in 1999?
Offer a terse response. 7.05. What is the difference between the Gross enrolment ratio (%) in Primary schools in 1998 and the Gross enrolment ratio (%) in Tertiary schools in 1999?
Offer a very short reply. 88.45. What is the difference between the Gross enrolment ratio (%) in Secondary schools in 1998 and the Gross enrolment ratio (%) in Tertiary schools in 1999?
Give a very brief answer. 81.5. What is the difference between the Gross enrolment ratio (%) in Pre-primary schools in 1998 and the Gross enrolment ratio (%) in Primary schools in 2000?
Offer a very short reply. -73.71. What is the difference between the Gross enrolment ratio (%) of Pre-primary schools in 1998 and the Gross enrolment ratio (%) of Secondary schools in 2000?
Your response must be concise. -72.39. What is the difference between the Gross enrolment ratio (%) in Pre-primary schools in 1998 and the Gross enrolment ratio (%) in Tertiary schools in 2000?
Provide a succinct answer. 15.67. What is the difference between the Gross enrolment ratio (%) in Primary schools in 1998 and the Gross enrolment ratio (%) in Secondary schools in 2000?
Make the answer very short. 0.18. What is the difference between the Gross enrolment ratio (%) of Primary schools in 1998 and the Gross enrolment ratio (%) of Tertiary schools in 2000?
Your answer should be compact. 88.23. What is the difference between the Gross enrolment ratio (%) in Secondary schools in 1998 and the Gross enrolment ratio (%) in Tertiary schools in 2000?
Your response must be concise. 81.28. What is the difference between the Gross enrolment ratio (%) of Pre-primary schools in 1998 and the Gross enrolment ratio (%) of Primary schools in 2001?
Provide a short and direct response. -73.92. What is the difference between the Gross enrolment ratio (%) in Pre-primary schools in 1998 and the Gross enrolment ratio (%) in Secondary schools in 2001?
Ensure brevity in your answer.  -72.75. What is the difference between the Gross enrolment ratio (%) of Pre-primary schools in 1998 and the Gross enrolment ratio (%) of Tertiary schools in 2001?
Offer a terse response. 15.72. What is the difference between the Gross enrolment ratio (%) in Primary schools in 1998 and the Gross enrolment ratio (%) in Secondary schools in 2001?
Offer a terse response. -0.19. What is the difference between the Gross enrolment ratio (%) of Primary schools in 1998 and the Gross enrolment ratio (%) of Tertiary schools in 2001?
Your response must be concise. 88.29. What is the difference between the Gross enrolment ratio (%) in Secondary schools in 1998 and the Gross enrolment ratio (%) in Tertiary schools in 2001?
Provide a short and direct response. 81.34. What is the difference between the Gross enrolment ratio (%) of Pre-primary schools in 1998 and the Gross enrolment ratio (%) of Primary schools in 2002?
Give a very brief answer. -72.95. What is the difference between the Gross enrolment ratio (%) in Pre-primary schools in 1998 and the Gross enrolment ratio (%) in Secondary schools in 2002?
Make the answer very short. -75.69. What is the difference between the Gross enrolment ratio (%) of Pre-primary schools in 1998 and the Gross enrolment ratio (%) of Tertiary schools in 2002?
Make the answer very short. 15.66. What is the difference between the Gross enrolment ratio (%) of Primary schools in 1998 and the Gross enrolment ratio (%) of Secondary schools in 2002?
Keep it short and to the point. -3.12. What is the difference between the Gross enrolment ratio (%) of Primary schools in 1998 and the Gross enrolment ratio (%) of Tertiary schools in 2002?
Make the answer very short. 88.22. What is the difference between the Gross enrolment ratio (%) in Secondary schools in 1998 and the Gross enrolment ratio (%) in Tertiary schools in 2002?
Offer a very short reply. 81.27. What is the difference between the Gross enrolment ratio (%) in Pre-primary schools in 1998 and the Gross enrolment ratio (%) in Primary schools in 2003?
Give a very brief answer. -71.88. What is the difference between the Gross enrolment ratio (%) of Pre-primary schools in 1998 and the Gross enrolment ratio (%) of Secondary schools in 2003?
Keep it short and to the point. -75.74. What is the difference between the Gross enrolment ratio (%) of Pre-primary schools in 1998 and the Gross enrolment ratio (%) of Tertiary schools in 2003?
Give a very brief answer. 15.83. What is the difference between the Gross enrolment ratio (%) of Primary schools in 1998 and the Gross enrolment ratio (%) of Secondary schools in 2003?
Ensure brevity in your answer.  -3.18. What is the difference between the Gross enrolment ratio (%) in Primary schools in 1998 and the Gross enrolment ratio (%) in Tertiary schools in 2003?
Your answer should be compact. 88.4. What is the difference between the Gross enrolment ratio (%) in Secondary schools in 1998 and the Gross enrolment ratio (%) in Tertiary schools in 2003?
Your response must be concise. 81.44. What is the difference between the Gross enrolment ratio (%) of Pre-primary schools in 1999 and the Gross enrolment ratio (%) of Primary schools in 2000?
Make the answer very short. -75.86. What is the difference between the Gross enrolment ratio (%) in Pre-primary schools in 1999 and the Gross enrolment ratio (%) in Secondary schools in 2000?
Ensure brevity in your answer.  -74.54. What is the difference between the Gross enrolment ratio (%) of Pre-primary schools in 1999 and the Gross enrolment ratio (%) of Tertiary schools in 2000?
Provide a short and direct response. 13.52. What is the difference between the Gross enrolment ratio (%) of Primary schools in 1999 and the Gross enrolment ratio (%) of Secondary schools in 2000?
Your response must be concise. 0.5. What is the difference between the Gross enrolment ratio (%) in Primary schools in 1999 and the Gross enrolment ratio (%) in Tertiary schools in 2000?
Offer a terse response. 88.55. What is the difference between the Gross enrolment ratio (%) in Secondary schools in 1999 and the Gross enrolment ratio (%) in Tertiary schools in 2000?
Make the answer very short. 81.18. What is the difference between the Gross enrolment ratio (%) of Pre-primary schools in 1999 and the Gross enrolment ratio (%) of Primary schools in 2001?
Make the answer very short. -76.07. What is the difference between the Gross enrolment ratio (%) in Pre-primary schools in 1999 and the Gross enrolment ratio (%) in Secondary schools in 2001?
Provide a succinct answer. -74.9. What is the difference between the Gross enrolment ratio (%) in Pre-primary schools in 1999 and the Gross enrolment ratio (%) in Tertiary schools in 2001?
Keep it short and to the point. 13.57. What is the difference between the Gross enrolment ratio (%) in Primary schools in 1999 and the Gross enrolment ratio (%) in Secondary schools in 2001?
Your answer should be very brief. 0.13. What is the difference between the Gross enrolment ratio (%) in Primary schools in 1999 and the Gross enrolment ratio (%) in Tertiary schools in 2001?
Your response must be concise. 88.61. What is the difference between the Gross enrolment ratio (%) in Secondary schools in 1999 and the Gross enrolment ratio (%) in Tertiary schools in 2001?
Your answer should be compact. 81.24. What is the difference between the Gross enrolment ratio (%) of Pre-primary schools in 1999 and the Gross enrolment ratio (%) of Primary schools in 2002?
Provide a short and direct response. -75.1. What is the difference between the Gross enrolment ratio (%) of Pre-primary schools in 1999 and the Gross enrolment ratio (%) of Secondary schools in 2002?
Provide a succinct answer. -77.84. What is the difference between the Gross enrolment ratio (%) in Pre-primary schools in 1999 and the Gross enrolment ratio (%) in Tertiary schools in 2002?
Your answer should be compact. 13.51. What is the difference between the Gross enrolment ratio (%) of Primary schools in 1999 and the Gross enrolment ratio (%) of Secondary schools in 2002?
Keep it short and to the point. -2.8. What is the difference between the Gross enrolment ratio (%) of Primary schools in 1999 and the Gross enrolment ratio (%) of Tertiary schools in 2002?
Ensure brevity in your answer.  88.54. What is the difference between the Gross enrolment ratio (%) in Secondary schools in 1999 and the Gross enrolment ratio (%) in Tertiary schools in 2002?
Your response must be concise. 81.17. What is the difference between the Gross enrolment ratio (%) in Pre-primary schools in 1999 and the Gross enrolment ratio (%) in Primary schools in 2003?
Provide a succinct answer. -74.03. What is the difference between the Gross enrolment ratio (%) in Pre-primary schools in 1999 and the Gross enrolment ratio (%) in Secondary schools in 2003?
Provide a short and direct response. -77.89. What is the difference between the Gross enrolment ratio (%) of Pre-primary schools in 1999 and the Gross enrolment ratio (%) of Tertiary schools in 2003?
Provide a short and direct response. 13.68. What is the difference between the Gross enrolment ratio (%) in Primary schools in 1999 and the Gross enrolment ratio (%) in Secondary schools in 2003?
Your answer should be compact. -2.86. What is the difference between the Gross enrolment ratio (%) of Primary schools in 1999 and the Gross enrolment ratio (%) of Tertiary schools in 2003?
Keep it short and to the point. 88.72. What is the difference between the Gross enrolment ratio (%) of Secondary schools in 1999 and the Gross enrolment ratio (%) of Tertiary schools in 2003?
Your answer should be very brief. 81.35. What is the difference between the Gross enrolment ratio (%) in Pre-primary schools in 2000 and the Gross enrolment ratio (%) in Primary schools in 2001?
Your answer should be compact. -75.93. What is the difference between the Gross enrolment ratio (%) of Pre-primary schools in 2000 and the Gross enrolment ratio (%) of Secondary schools in 2001?
Your answer should be compact. -74.76. What is the difference between the Gross enrolment ratio (%) of Pre-primary schools in 2000 and the Gross enrolment ratio (%) of Tertiary schools in 2001?
Ensure brevity in your answer.  13.71. What is the difference between the Gross enrolment ratio (%) in Primary schools in 2000 and the Gross enrolment ratio (%) in Secondary schools in 2001?
Give a very brief answer. 0.95. What is the difference between the Gross enrolment ratio (%) in Primary schools in 2000 and the Gross enrolment ratio (%) in Tertiary schools in 2001?
Offer a terse response. 89.43. What is the difference between the Gross enrolment ratio (%) in Secondary schools in 2000 and the Gross enrolment ratio (%) in Tertiary schools in 2001?
Provide a succinct answer. 88.11. What is the difference between the Gross enrolment ratio (%) in Pre-primary schools in 2000 and the Gross enrolment ratio (%) in Primary schools in 2002?
Provide a succinct answer. -74.96. What is the difference between the Gross enrolment ratio (%) in Pre-primary schools in 2000 and the Gross enrolment ratio (%) in Secondary schools in 2002?
Provide a short and direct response. -77.7. What is the difference between the Gross enrolment ratio (%) of Pre-primary schools in 2000 and the Gross enrolment ratio (%) of Tertiary schools in 2002?
Your response must be concise. 13.65. What is the difference between the Gross enrolment ratio (%) in Primary schools in 2000 and the Gross enrolment ratio (%) in Secondary schools in 2002?
Offer a very short reply. -1.98. What is the difference between the Gross enrolment ratio (%) of Primary schools in 2000 and the Gross enrolment ratio (%) of Tertiary schools in 2002?
Make the answer very short. 89.36. What is the difference between the Gross enrolment ratio (%) of Secondary schools in 2000 and the Gross enrolment ratio (%) of Tertiary schools in 2002?
Make the answer very short. 88.04. What is the difference between the Gross enrolment ratio (%) of Pre-primary schools in 2000 and the Gross enrolment ratio (%) of Primary schools in 2003?
Ensure brevity in your answer.  -73.89. What is the difference between the Gross enrolment ratio (%) of Pre-primary schools in 2000 and the Gross enrolment ratio (%) of Secondary schools in 2003?
Your response must be concise. -77.75. What is the difference between the Gross enrolment ratio (%) in Pre-primary schools in 2000 and the Gross enrolment ratio (%) in Tertiary schools in 2003?
Your answer should be very brief. 13.82. What is the difference between the Gross enrolment ratio (%) of Primary schools in 2000 and the Gross enrolment ratio (%) of Secondary schools in 2003?
Make the answer very short. -2.04. What is the difference between the Gross enrolment ratio (%) of Primary schools in 2000 and the Gross enrolment ratio (%) of Tertiary schools in 2003?
Provide a short and direct response. 89.54. What is the difference between the Gross enrolment ratio (%) in Secondary schools in 2000 and the Gross enrolment ratio (%) in Tertiary schools in 2003?
Ensure brevity in your answer.  88.22. What is the difference between the Gross enrolment ratio (%) of Pre-primary schools in 2001 and the Gross enrolment ratio (%) of Primary schools in 2002?
Offer a very short reply. -73.76. What is the difference between the Gross enrolment ratio (%) of Pre-primary schools in 2001 and the Gross enrolment ratio (%) of Secondary schools in 2002?
Ensure brevity in your answer.  -76.49. What is the difference between the Gross enrolment ratio (%) in Pre-primary schools in 2001 and the Gross enrolment ratio (%) in Tertiary schools in 2002?
Keep it short and to the point. 14.85. What is the difference between the Gross enrolment ratio (%) in Primary schools in 2001 and the Gross enrolment ratio (%) in Secondary schools in 2002?
Give a very brief answer. -1.77. What is the difference between the Gross enrolment ratio (%) of Primary schools in 2001 and the Gross enrolment ratio (%) of Tertiary schools in 2002?
Your answer should be compact. 89.57. What is the difference between the Gross enrolment ratio (%) of Secondary schools in 2001 and the Gross enrolment ratio (%) of Tertiary schools in 2002?
Offer a very short reply. 88.41. What is the difference between the Gross enrolment ratio (%) of Pre-primary schools in 2001 and the Gross enrolment ratio (%) of Primary schools in 2003?
Provide a succinct answer. -72.68. What is the difference between the Gross enrolment ratio (%) of Pre-primary schools in 2001 and the Gross enrolment ratio (%) of Secondary schools in 2003?
Your response must be concise. -76.55. What is the difference between the Gross enrolment ratio (%) of Pre-primary schools in 2001 and the Gross enrolment ratio (%) of Tertiary schools in 2003?
Provide a succinct answer. 15.02. What is the difference between the Gross enrolment ratio (%) of Primary schools in 2001 and the Gross enrolment ratio (%) of Secondary schools in 2003?
Offer a very short reply. -1.83. What is the difference between the Gross enrolment ratio (%) in Primary schools in 2001 and the Gross enrolment ratio (%) in Tertiary schools in 2003?
Provide a short and direct response. 89.75. What is the difference between the Gross enrolment ratio (%) of Secondary schools in 2001 and the Gross enrolment ratio (%) of Tertiary schools in 2003?
Give a very brief answer. 88.58. What is the difference between the Gross enrolment ratio (%) in Pre-primary schools in 2002 and the Gross enrolment ratio (%) in Primary schools in 2003?
Offer a terse response. -71.18. What is the difference between the Gross enrolment ratio (%) in Pre-primary schools in 2002 and the Gross enrolment ratio (%) in Secondary schools in 2003?
Offer a very short reply. -75.05. What is the difference between the Gross enrolment ratio (%) of Pre-primary schools in 2002 and the Gross enrolment ratio (%) of Tertiary schools in 2003?
Provide a succinct answer. 16.53. What is the difference between the Gross enrolment ratio (%) of Primary schools in 2002 and the Gross enrolment ratio (%) of Secondary schools in 2003?
Your answer should be compact. -2.79. What is the difference between the Gross enrolment ratio (%) of Primary schools in 2002 and the Gross enrolment ratio (%) of Tertiary schools in 2003?
Keep it short and to the point. 88.78. What is the difference between the Gross enrolment ratio (%) of Secondary schools in 2002 and the Gross enrolment ratio (%) of Tertiary schools in 2003?
Provide a short and direct response. 91.52. What is the average Gross enrolment ratio (%) of Pre-primary schools per year?
Your answer should be very brief. 28.51. What is the average Gross enrolment ratio (%) in Primary schools per year?
Give a very brief answer. 99.62. What is the average Gross enrolment ratio (%) of Secondary schools per year?
Make the answer very short. 94.33. What is the average Gross enrolment ratio (%) of Tertiary schools per year?
Give a very brief answer. 11.71. In the year 1995, what is the difference between the Gross enrolment ratio (%) of Pre-primary schools and Gross enrolment ratio (%) of Primary schools?
Ensure brevity in your answer.  -64.36. In the year 1995, what is the difference between the Gross enrolment ratio (%) in Pre-primary schools and Gross enrolment ratio (%) in Secondary schools?
Your answer should be compact. -51.06. In the year 1995, what is the difference between the Gross enrolment ratio (%) in Pre-primary schools and Gross enrolment ratio (%) in Tertiary schools?
Ensure brevity in your answer.  27.46. In the year 1995, what is the difference between the Gross enrolment ratio (%) in Primary schools and Gross enrolment ratio (%) in Secondary schools?
Make the answer very short. 13.3. In the year 1995, what is the difference between the Gross enrolment ratio (%) of Primary schools and Gross enrolment ratio (%) of Tertiary schools?
Give a very brief answer. 91.82. In the year 1995, what is the difference between the Gross enrolment ratio (%) in Secondary schools and Gross enrolment ratio (%) in Tertiary schools?
Ensure brevity in your answer.  78.52. In the year 1996, what is the difference between the Gross enrolment ratio (%) in Pre-primary schools and Gross enrolment ratio (%) in Primary schools?
Provide a succinct answer. -63.98. In the year 1996, what is the difference between the Gross enrolment ratio (%) in Pre-primary schools and Gross enrolment ratio (%) in Secondary schools?
Offer a terse response. -50.84. In the year 1996, what is the difference between the Gross enrolment ratio (%) of Pre-primary schools and Gross enrolment ratio (%) of Tertiary schools?
Keep it short and to the point. 22.23. In the year 1996, what is the difference between the Gross enrolment ratio (%) of Primary schools and Gross enrolment ratio (%) of Secondary schools?
Ensure brevity in your answer.  13.13. In the year 1996, what is the difference between the Gross enrolment ratio (%) of Primary schools and Gross enrolment ratio (%) of Tertiary schools?
Offer a very short reply. 86.21. In the year 1996, what is the difference between the Gross enrolment ratio (%) of Secondary schools and Gross enrolment ratio (%) of Tertiary schools?
Offer a terse response. 73.08. In the year 1997, what is the difference between the Gross enrolment ratio (%) of Pre-primary schools and Gross enrolment ratio (%) of Primary schools?
Your answer should be very brief. -70.66. In the year 1997, what is the difference between the Gross enrolment ratio (%) in Pre-primary schools and Gross enrolment ratio (%) in Secondary schools?
Your answer should be very brief. -59.7. In the year 1997, what is the difference between the Gross enrolment ratio (%) in Pre-primary schools and Gross enrolment ratio (%) in Tertiary schools?
Make the answer very short. 14.41. In the year 1997, what is the difference between the Gross enrolment ratio (%) of Primary schools and Gross enrolment ratio (%) of Secondary schools?
Ensure brevity in your answer.  10.96. In the year 1997, what is the difference between the Gross enrolment ratio (%) of Primary schools and Gross enrolment ratio (%) of Tertiary schools?
Keep it short and to the point. 85.07. In the year 1997, what is the difference between the Gross enrolment ratio (%) in Secondary schools and Gross enrolment ratio (%) in Tertiary schools?
Your answer should be compact. 74.11. In the year 1998, what is the difference between the Gross enrolment ratio (%) in Pre-primary schools and Gross enrolment ratio (%) in Primary schools?
Give a very brief answer. -72.57. In the year 1998, what is the difference between the Gross enrolment ratio (%) in Pre-primary schools and Gross enrolment ratio (%) in Secondary schools?
Your response must be concise. -65.61. In the year 1998, what is the difference between the Gross enrolment ratio (%) of Pre-primary schools and Gross enrolment ratio (%) of Tertiary schools?
Your answer should be compact. 11.36. In the year 1998, what is the difference between the Gross enrolment ratio (%) of Primary schools and Gross enrolment ratio (%) of Secondary schools?
Offer a terse response. 6.95. In the year 1998, what is the difference between the Gross enrolment ratio (%) in Primary schools and Gross enrolment ratio (%) in Tertiary schools?
Give a very brief answer. 83.93. In the year 1998, what is the difference between the Gross enrolment ratio (%) in Secondary schools and Gross enrolment ratio (%) in Tertiary schools?
Offer a terse response. 76.98. In the year 1999, what is the difference between the Gross enrolment ratio (%) of Pre-primary schools and Gross enrolment ratio (%) of Primary schools?
Offer a terse response. -75.03. In the year 1999, what is the difference between the Gross enrolment ratio (%) of Pre-primary schools and Gross enrolment ratio (%) of Secondary schools?
Offer a terse response. -67.66. In the year 1999, what is the difference between the Gross enrolment ratio (%) of Pre-primary schools and Gross enrolment ratio (%) of Tertiary schools?
Make the answer very short. 13.73. In the year 1999, what is the difference between the Gross enrolment ratio (%) in Primary schools and Gross enrolment ratio (%) in Secondary schools?
Your answer should be very brief. 7.37. In the year 1999, what is the difference between the Gross enrolment ratio (%) of Primary schools and Gross enrolment ratio (%) of Tertiary schools?
Give a very brief answer. 88.77. In the year 1999, what is the difference between the Gross enrolment ratio (%) in Secondary schools and Gross enrolment ratio (%) in Tertiary schools?
Make the answer very short. 81.4. In the year 2000, what is the difference between the Gross enrolment ratio (%) of Pre-primary schools and Gross enrolment ratio (%) of Primary schools?
Provide a succinct answer. -75.72. In the year 2000, what is the difference between the Gross enrolment ratio (%) of Pre-primary schools and Gross enrolment ratio (%) of Secondary schools?
Provide a succinct answer. -74.4. In the year 2000, what is the difference between the Gross enrolment ratio (%) of Pre-primary schools and Gross enrolment ratio (%) of Tertiary schools?
Your answer should be compact. 13.66. In the year 2000, what is the difference between the Gross enrolment ratio (%) of Primary schools and Gross enrolment ratio (%) of Secondary schools?
Give a very brief answer. 1.32. In the year 2000, what is the difference between the Gross enrolment ratio (%) in Primary schools and Gross enrolment ratio (%) in Tertiary schools?
Give a very brief answer. 89.37. In the year 2000, what is the difference between the Gross enrolment ratio (%) of Secondary schools and Gross enrolment ratio (%) of Tertiary schools?
Your answer should be very brief. 88.05. In the year 2001, what is the difference between the Gross enrolment ratio (%) of Pre-primary schools and Gross enrolment ratio (%) of Primary schools?
Ensure brevity in your answer.  -74.72. In the year 2001, what is the difference between the Gross enrolment ratio (%) in Pre-primary schools and Gross enrolment ratio (%) in Secondary schools?
Keep it short and to the point. -73.56. In the year 2001, what is the difference between the Gross enrolment ratio (%) in Pre-primary schools and Gross enrolment ratio (%) in Tertiary schools?
Provide a succinct answer. 14.92. In the year 2001, what is the difference between the Gross enrolment ratio (%) of Primary schools and Gross enrolment ratio (%) of Secondary schools?
Give a very brief answer. 1.16. In the year 2001, what is the difference between the Gross enrolment ratio (%) of Primary schools and Gross enrolment ratio (%) of Tertiary schools?
Provide a short and direct response. 89.64. In the year 2001, what is the difference between the Gross enrolment ratio (%) of Secondary schools and Gross enrolment ratio (%) of Tertiary schools?
Keep it short and to the point. 88.48. In the year 2002, what is the difference between the Gross enrolment ratio (%) in Pre-primary schools and Gross enrolment ratio (%) in Primary schools?
Your response must be concise. -72.25. In the year 2002, what is the difference between the Gross enrolment ratio (%) in Pre-primary schools and Gross enrolment ratio (%) in Secondary schools?
Make the answer very short. -74.99. In the year 2002, what is the difference between the Gross enrolment ratio (%) in Pre-primary schools and Gross enrolment ratio (%) in Tertiary schools?
Give a very brief answer. 16.35. In the year 2002, what is the difference between the Gross enrolment ratio (%) of Primary schools and Gross enrolment ratio (%) of Secondary schools?
Give a very brief answer. -2.74. In the year 2002, what is the difference between the Gross enrolment ratio (%) of Primary schools and Gross enrolment ratio (%) of Tertiary schools?
Make the answer very short. 88.61. In the year 2002, what is the difference between the Gross enrolment ratio (%) in Secondary schools and Gross enrolment ratio (%) in Tertiary schools?
Offer a very short reply. 91.34. In the year 2003, what is the difference between the Gross enrolment ratio (%) of Pre-primary schools and Gross enrolment ratio (%) of Primary schools?
Make the answer very short. -70.63. In the year 2003, what is the difference between the Gross enrolment ratio (%) in Pre-primary schools and Gross enrolment ratio (%) in Secondary schools?
Give a very brief answer. -74.5. In the year 2003, what is the difference between the Gross enrolment ratio (%) in Pre-primary schools and Gross enrolment ratio (%) in Tertiary schools?
Ensure brevity in your answer.  17.08. In the year 2003, what is the difference between the Gross enrolment ratio (%) of Primary schools and Gross enrolment ratio (%) of Secondary schools?
Your response must be concise. -3.87. In the year 2003, what is the difference between the Gross enrolment ratio (%) in Primary schools and Gross enrolment ratio (%) in Tertiary schools?
Keep it short and to the point. 87.71. In the year 2003, what is the difference between the Gross enrolment ratio (%) in Secondary schools and Gross enrolment ratio (%) in Tertiary schools?
Your answer should be very brief. 91.58. What is the ratio of the Gross enrolment ratio (%) of Pre-primary schools in 1995 to that in 1996?
Offer a very short reply. 1.13. What is the ratio of the Gross enrolment ratio (%) of Primary schools in 1995 to that in 1996?
Your response must be concise. 1.05. What is the ratio of the Gross enrolment ratio (%) in Secondary schools in 1995 to that in 1996?
Provide a short and direct response. 1.06. What is the ratio of the Gross enrolment ratio (%) in Tertiary schools in 1995 to that in 1996?
Offer a very short reply. 0.95. What is the ratio of the Gross enrolment ratio (%) in Pre-primary schools in 1995 to that in 1997?
Offer a very short reply. 1.42. What is the ratio of the Gross enrolment ratio (%) in Primary schools in 1995 to that in 1997?
Make the answer very short. 1.06. What is the ratio of the Gross enrolment ratio (%) of Secondary schools in 1995 to that in 1997?
Give a very brief answer. 1.04. What is the ratio of the Gross enrolment ratio (%) of Tertiary schools in 1995 to that in 1997?
Provide a succinct answer. 0.93. What is the ratio of the Gross enrolment ratio (%) in Pre-primary schools in 1995 to that in 1998?
Keep it short and to the point. 1.57. What is the ratio of the Gross enrolment ratio (%) in Primary schools in 1995 to that in 1998?
Provide a short and direct response. 1.07. What is the ratio of the Gross enrolment ratio (%) in Secondary schools in 1995 to that in 1998?
Give a very brief answer. 1. What is the ratio of the Gross enrolment ratio (%) in Tertiary schools in 1995 to that in 1998?
Offer a very short reply. 0.91. What is the ratio of the Gross enrolment ratio (%) of Pre-primary schools in 1995 to that in 1999?
Keep it short and to the point. 1.72. What is the ratio of the Gross enrolment ratio (%) in Primary schools in 1995 to that in 1999?
Provide a succinct answer. 1.06. What is the ratio of the Gross enrolment ratio (%) in Secondary schools in 1995 to that in 1999?
Give a very brief answer. 1. What is the ratio of the Gross enrolment ratio (%) in Tertiary schools in 1995 to that in 1999?
Offer a terse response. 1.32. What is the ratio of the Gross enrolment ratio (%) in Pre-primary schools in 1995 to that in 2000?
Give a very brief answer. 1.71. What is the ratio of the Gross enrolment ratio (%) of Primary schools in 1995 to that in 2000?
Give a very brief answer. 1.05. What is the ratio of the Gross enrolment ratio (%) in Secondary schools in 1995 to that in 2000?
Offer a terse response. 0.93. What is the ratio of the Gross enrolment ratio (%) of Tertiary schools in 1995 to that in 2000?
Keep it short and to the point. 1.29. What is the ratio of the Gross enrolment ratio (%) in Pre-primary schools in 1995 to that in 2001?
Provide a short and direct response. 1.62. What is the ratio of the Gross enrolment ratio (%) of Primary schools in 1995 to that in 2001?
Your answer should be compact. 1.05. What is the ratio of the Gross enrolment ratio (%) of Secondary schools in 1995 to that in 2001?
Make the answer very short. 0.93. What is the ratio of the Gross enrolment ratio (%) of Tertiary schools in 1995 to that in 2001?
Your response must be concise. 1.3. What is the ratio of the Gross enrolment ratio (%) in Pre-primary schools in 1995 to that in 2002?
Offer a terse response. 1.53. What is the ratio of the Gross enrolment ratio (%) in Primary schools in 1995 to that in 2002?
Offer a very short reply. 1.06. What is the ratio of the Gross enrolment ratio (%) in Secondary schools in 1995 to that in 2002?
Offer a very short reply. 0.9. What is the ratio of the Gross enrolment ratio (%) of Tertiary schools in 1995 to that in 2002?
Offer a terse response. 1.29. What is the ratio of the Gross enrolment ratio (%) in Pre-primary schools in 1995 to that in 2003?
Give a very brief answer. 1.5. What is the ratio of the Gross enrolment ratio (%) in Primary schools in 1995 to that in 2003?
Your answer should be compact. 1.07. What is the ratio of the Gross enrolment ratio (%) of Secondary schools in 1995 to that in 2003?
Give a very brief answer. 0.9. What is the ratio of the Gross enrolment ratio (%) of Tertiary schools in 1995 to that in 2003?
Keep it short and to the point. 1.32. What is the ratio of the Gross enrolment ratio (%) in Pre-primary schools in 1996 to that in 1997?
Offer a terse response. 1.26. What is the ratio of the Gross enrolment ratio (%) in Secondary schools in 1996 to that in 1997?
Keep it short and to the point. 0.98. What is the ratio of the Gross enrolment ratio (%) of Tertiary schools in 1996 to that in 1997?
Keep it short and to the point. 0.98. What is the ratio of the Gross enrolment ratio (%) in Pre-primary schools in 1996 to that in 1998?
Provide a succinct answer. 1.4. What is the ratio of the Gross enrolment ratio (%) in Primary schools in 1996 to that in 1998?
Offer a very short reply. 1.02. What is the ratio of the Gross enrolment ratio (%) in Secondary schools in 1996 to that in 1998?
Provide a succinct answer. 0.95. What is the ratio of the Gross enrolment ratio (%) in Tertiary schools in 1996 to that in 1998?
Your response must be concise. 0.95. What is the ratio of the Gross enrolment ratio (%) in Pre-primary schools in 1996 to that in 1999?
Provide a succinct answer. 1.52. What is the ratio of the Gross enrolment ratio (%) of Primary schools in 1996 to that in 1999?
Ensure brevity in your answer.  1.01. What is the ratio of the Gross enrolment ratio (%) in Secondary schools in 1996 to that in 1999?
Offer a very short reply. 0.95. What is the ratio of the Gross enrolment ratio (%) in Tertiary schools in 1996 to that in 1999?
Provide a succinct answer. 1.39. What is the ratio of the Gross enrolment ratio (%) in Pre-primary schools in 1996 to that in 2000?
Keep it short and to the point. 1.51. What is the ratio of the Gross enrolment ratio (%) of Secondary schools in 1996 to that in 2000?
Your answer should be very brief. 0.88. What is the ratio of the Gross enrolment ratio (%) of Tertiary schools in 1996 to that in 2000?
Give a very brief answer. 1.36. What is the ratio of the Gross enrolment ratio (%) in Pre-primary schools in 1996 to that in 2001?
Offer a terse response. 1.44. What is the ratio of the Gross enrolment ratio (%) in Primary schools in 1996 to that in 2001?
Your response must be concise. 1. What is the ratio of the Gross enrolment ratio (%) of Secondary schools in 1996 to that in 2001?
Give a very brief answer. 0.88. What is the ratio of the Gross enrolment ratio (%) of Tertiary schools in 1996 to that in 2001?
Provide a succinct answer. 1.37. What is the ratio of the Gross enrolment ratio (%) of Pre-primary schools in 1996 to that in 2002?
Your answer should be compact. 1.36. What is the ratio of the Gross enrolment ratio (%) in Primary schools in 1996 to that in 2002?
Offer a very short reply. 1.01. What is the ratio of the Gross enrolment ratio (%) of Secondary schools in 1996 to that in 2002?
Your answer should be very brief. 0.86. What is the ratio of the Gross enrolment ratio (%) of Tertiary schools in 1996 to that in 2002?
Provide a succinct answer. 1.36. What is the ratio of the Gross enrolment ratio (%) in Pre-primary schools in 1996 to that in 2003?
Give a very brief answer. 1.33. What is the ratio of the Gross enrolment ratio (%) of Primary schools in 1996 to that in 2003?
Ensure brevity in your answer.  1.02. What is the ratio of the Gross enrolment ratio (%) of Secondary schools in 1996 to that in 2003?
Keep it short and to the point. 0.85. What is the ratio of the Gross enrolment ratio (%) of Tertiary schools in 1996 to that in 2003?
Make the answer very short. 1.38. What is the ratio of the Gross enrolment ratio (%) in Pre-primary schools in 1997 to that in 1998?
Your response must be concise. 1.1. What is the ratio of the Gross enrolment ratio (%) in Secondary schools in 1997 to that in 1998?
Ensure brevity in your answer.  0.96. What is the ratio of the Gross enrolment ratio (%) in Tertiary schools in 1997 to that in 1998?
Keep it short and to the point. 0.98. What is the ratio of the Gross enrolment ratio (%) in Pre-primary schools in 1997 to that in 1999?
Give a very brief answer. 1.21. What is the ratio of the Gross enrolment ratio (%) in Primary schools in 1997 to that in 1999?
Your response must be concise. 1. What is the ratio of the Gross enrolment ratio (%) in Secondary schools in 1997 to that in 1999?
Your answer should be very brief. 0.97. What is the ratio of the Gross enrolment ratio (%) of Tertiary schools in 1997 to that in 1999?
Offer a terse response. 1.42. What is the ratio of the Gross enrolment ratio (%) of Pre-primary schools in 1997 to that in 2000?
Offer a terse response. 1.2. What is the ratio of the Gross enrolment ratio (%) of Secondary schools in 1997 to that in 2000?
Provide a short and direct response. 0.9. What is the ratio of the Gross enrolment ratio (%) of Tertiary schools in 1997 to that in 2000?
Your answer should be very brief. 1.39. What is the ratio of the Gross enrolment ratio (%) in Pre-primary schools in 1997 to that in 2001?
Give a very brief answer. 1.14. What is the ratio of the Gross enrolment ratio (%) of Primary schools in 1997 to that in 2001?
Offer a very short reply. 0.99. What is the ratio of the Gross enrolment ratio (%) in Secondary schools in 1997 to that in 2001?
Offer a very short reply. 0.89. What is the ratio of the Gross enrolment ratio (%) of Tertiary schools in 1997 to that in 2001?
Make the answer very short. 1.4. What is the ratio of the Gross enrolment ratio (%) in Pre-primary schools in 1997 to that in 2002?
Make the answer very short. 1.08. What is the ratio of the Gross enrolment ratio (%) in Secondary schools in 1997 to that in 2002?
Keep it short and to the point. 0.87. What is the ratio of the Gross enrolment ratio (%) in Tertiary schools in 1997 to that in 2002?
Provide a short and direct response. 1.39. What is the ratio of the Gross enrolment ratio (%) in Pre-primary schools in 1997 to that in 2003?
Make the answer very short. 1.05. What is the ratio of the Gross enrolment ratio (%) of Primary schools in 1997 to that in 2003?
Your answer should be very brief. 1.02. What is the ratio of the Gross enrolment ratio (%) in Secondary schools in 1997 to that in 2003?
Your answer should be compact. 0.87. What is the ratio of the Gross enrolment ratio (%) of Tertiary schools in 1997 to that in 2003?
Provide a short and direct response. 1.41. What is the ratio of the Gross enrolment ratio (%) of Pre-primary schools in 1998 to that in 1999?
Keep it short and to the point. 1.09. What is the ratio of the Gross enrolment ratio (%) of Primary schools in 1998 to that in 1999?
Offer a very short reply. 1. What is the ratio of the Gross enrolment ratio (%) in Tertiary schools in 1998 to that in 1999?
Ensure brevity in your answer.  1.46. What is the ratio of the Gross enrolment ratio (%) in Pre-primary schools in 1998 to that in 2000?
Your response must be concise. 1.08. What is the ratio of the Gross enrolment ratio (%) in Secondary schools in 1998 to that in 2000?
Offer a very short reply. 0.93. What is the ratio of the Gross enrolment ratio (%) in Tertiary schools in 1998 to that in 2000?
Offer a very short reply. 1.43. What is the ratio of the Gross enrolment ratio (%) of Pre-primary schools in 1998 to that in 2001?
Ensure brevity in your answer.  1.03. What is the ratio of the Gross enrolment ratio (%) in Primary schools in 1998 to that in 2001?
Your answer should be very brief. 0.99. What is the ratio of the Gross enrolment ratio (%) in Secondary schools in 1998 to that in 2001?
Your answer should be compact. 0.93. What is the ratio of the Gross enrolment ratio (%) of Tertiary schools in 1998 to that in 2001?
Ensure brevity in your answer.  1.43. What is the ratio of the Gross enrolment ratio (%) of Pre-primary schools in 1998 to that in 2002?
Provide a short and direct response. 0.97. What is the ratio of the Gross enrolment ratio (%) in Secondary schools in 1998 to that in 2002?
Provide a succinct answer. 0.9. What is the ratio of the Gross enrolment ratio (%) in Tertiary schools in 1998 to that in 2002?
Offer a terse response. 1.42. What is the ratio of the Gross enrolment ratio (%) in Pre-primary schools in 1998 to that in 2003?
Offer a terse response. 0.95. What is the ratio of the Gross enrolment ratio (%) in Primary schools in 1998 to that in 2003?
Your answer should be very brief. 1.01. What is the ratio of the Gross enrolment ratio (%) in Secondary schools in 1998 to that in 2003?
Provide a succinct answer. 0.9. What is the ratio of the Gross enrolment ratio (%) of Tertiary schools in 1998 to that in 2003?
Offer a very short reply. 1.45. What is the ratio of the Gross enrolment ratio (%) of Pre-primary schools in 1999 to that in 2000?
Provide a succinct answer. 0.99. What is the ratio of the Gross enrolment ratio (%) in Tertiary schools in 1999 to that in 2000?
Your answer should be very brief. 0.98. What is the ratio of the Gross enrolment ratio (%) of Pre-primary schools in 1999 to that in 2001?
Your answer should be compact. 0.95. What is the ratio of the Gross enrolment ratio (%) of Secondary schools in 1999 to that in 2001?
Give a very brief answer. 0.93. What is the ratio of the Gross enrolment ratio (%) of Tertiary schools in 1999 to that in 2001?
Give a very brief answer. 0.98. What is the ratio of the Gross enrolment ratio (%) of Pre-primary schools in 1999 to that in 2002?
Your answer should be compact. 0.89. What is the ratio of the Gross enrolment ratio (%) in Secondary schools in 1999 to that in 2002?
Give a very brief answer. 0.9. What is the ratio of the Gross enrolment ratio (%) of Tertiary schools in 1999 to that in 2002?
Your answer should be very brief. 0.98. What is the ratio of the Gross enrolment ratio (%) in Pre-primary schools in 1999 to that in 2003?
Your response must be concise. 0.87. What is the ratio of the Gross enrolment ratio (%) in Primary schools in 1999 to that in 2003?
Your answer should be very brief. 1.01. What is the ratio of the Gross enrolment ratio (%) of Secondary schools in 1999 to that in 2003?
Offer a terse response. 0.9. What is the ratio of the Gross enrolment ratio (%) in Pre-primary schools in 2000 to that in 2001?
Make the answer very short. 0.95. What is the ratio of the Gross enrolment ratio (%) in Primary schools in 2000 to that in 2001?
Offer a terse response. 1. What is the ratio of the Gross enrolment ratio (%) of Tertiary schools in 2000 to that in 2001?
Make the answer very short. 1.01. What is the ratio of the Gross enrolment ratio (%) of Pre-primary schools in 2000 to that in 2002?
Make the answer very short. 0.9. What is the ratio of the Gross enrolment ratio (%) in Primary schools in 2000 to that in 2002?
Your response must be concise. 1.01. What is the ratio of the Gross enrolment ratio (%) of Secondary schools in 2000 to that in 2002?
Ensure brevity in your answer.  0.97. What is the ratio of the Gross enrolment ratio (%) of Pre-primary schools in 2000 to that in 2003?
Your answer should be compact. 0.88. What is the ratio of the Gross enrolment ratio (%) in Primary schools in 2000 to that in 2003?
Your answer should be compact. 1.02. What is the ratio of the Gross enrolment ratio (%) of Secondary schools in 2000 to that in 2003?
Offer a terse response. 0.97. What is the ratio of the Gross enrolment ratio (%) in Tertiary schools in 2000 to that in 2003?
Provide a succinct answer. 1.02. What is the ratio of the Gross enrolment ratio (%) of Pre-primary schools in 2001 to that in 2002?
Offer a terse response. 0.94. What is the ratio of the Gross enrolment ratio (%) in Primary schools in 2001 to that in 2002?
Make the answer very short. 1.01. What is the ratio of the Gross enrolment ratio (%) of Secondary schools in 2001 to that in 2002?
Your answer should be very brief. 0.97. What is the ratio of the Gross enrolment ratio (%) of Pre-primary schools in 2001 to that in 2003?
Make the answer very short. 0.92. What is the ratio of the Gross enrolment ratio (%) of Primary schools in 2001 to that in 2003?
Make the answer very short. 1.02. What is the ratio of the Gross enrolment ratio (%) of Secondary schools in 2001 to that in 2003?
Your answer should be very brief. 0.97. What is the ratio of the Gross enrolment ratio (%) in Tertiary schools in 2001 to that in 2003?
Give a very brief answer. 1.01. What is the ratio of the Gross enrolment ratio (%) of Pre-primary schools in 2002 to that in 2003?
Your answer should be compact. 0.98. What is the ratio of the Gross enrolment ratio (%) of Primary schools in 2002 to that in 2003?
Offer a terse response. 1.01. What is the ratio of the Gross enrolment ratio (%) of Tertiary schools in 2002 to that in 2003?
Ensure brevity in your answer.  1.02. What is the difference between the highest and the second highest Gross enrolment ratio (%) of Pre-primary schools?
Offer a very short reply. 4.58. What is the difference between the highest and the second highest Gross enrolment ratio (%) of Primary schools?
Your response must be concise. 4.96. What is the difference between the highest and the second highest Gross enrolment ratio (%) of Secondary schools?
Offer a terse response. 0.06. What is the difference between the highest and the second highest Gross enrolment ratio (%) in Tertiary schools?
Give a very brief answer. 0.34. What is the difference between the highest and the lowest Gross enrolment ratio (%) in Pre-primary schools?
Your answer should be compact. 16.91. What is the difference between the highest and the lowest Gross enrolment ratio (%) of Primary schools?
Keep it short and to the point. 7.24. What is the difference between the highest and the lowest Gross enrolment ratio (%) of Secondary schools?
Offer a very short reply. 14.72. What is the difference between the highest and the lowest Gross enrolment ratio (%) of Tertiary schools?
Your answer should be compact. 4.52. 